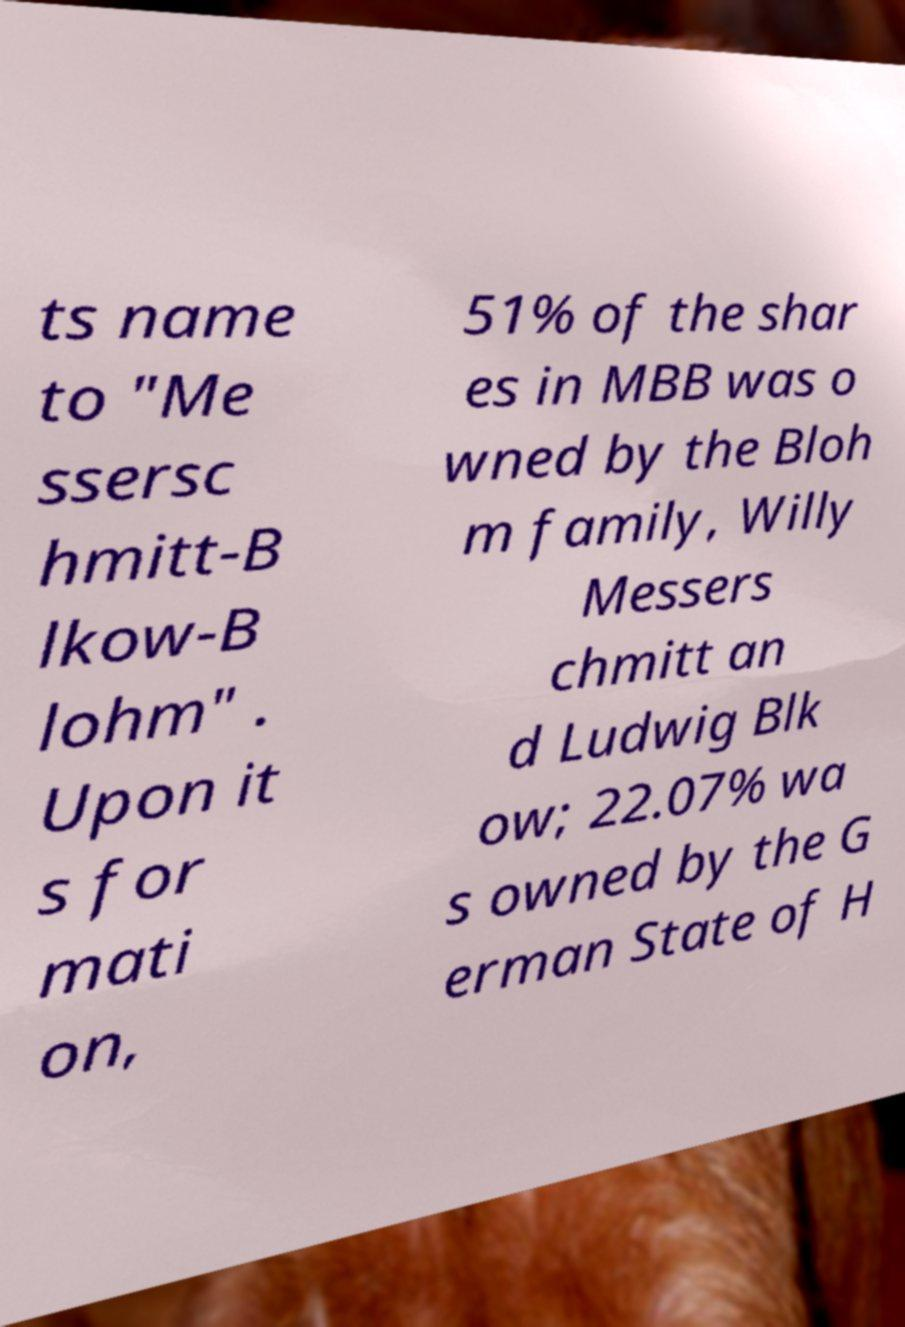Could you extract and type out the text from this image? ts name to "Me ssersc hmitt-B lkow-B lohm" . Upon it s for mati on, 51% of the shar es in MBB was o wned by the Bloh m family, Willy Messers chmitt an d Ludwig Blk ow; 22.07% wa s owned by the G erman State of H 